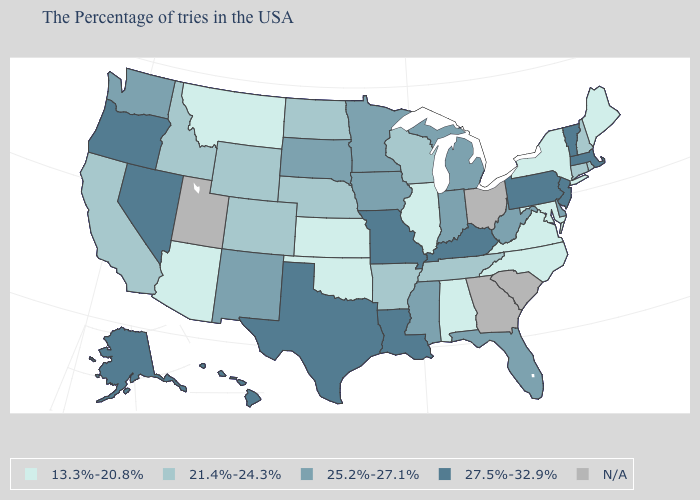Does Louisiana have the highest value in the South?
Write a very short answer. Yes. Name the states that have a value in the range 21.4%-24.3%?
Give a very brief answer. Rhode Island, New Hampshire, Connecticut, Tennessee, Wisconsin, Arkansas, Nebraska, North Dakota, Wyoming, Colorado, Idaho, California. What is the value of Nevada?
Answer briefly. 27.5%-32.9%. Which states have the lowest value in the South?
Concise answer only. Maryland, Virginia, North Carolina, Alabama, Oklahoma. What is the value of Connecticut?
Keep it brief. 21.4%-24.3%. What is the value of Arkansas?
Give a very brief answer. 21.4%-24.3%. What is the value of Washington?
Give a very brief answer. 25.2%-27.1%. What is the lowest value in the USA?
Answer briefly. 13.3%-20.8%. Name the states that have a value in the range 25.2%-27.1%?
Give a very brief answer. Delaware, West Virginia, Florida, Michigan, Indiana, Mississippi, Minnesota, Iowa, South Dakota, New Mexico, Washington. What is the value of Alaska?
Short answer required. 27.5%-32.9%. Does New York have the lowest value in the USA?
Concise answer only. Yes. What is the value of Louisiana?
Give a very brief answer. 27.5%-32.9%. Name the states that have a value in the range 27.5%-32.9%?
Be succinct. Massachusetts, Vermont, New Jersey, Pennsylvania, Kentucky, Louisiana, Missouri, Texas, Nevada, Oregon, Alaska, Hawaii. What is the lowest value in states that border Mississippi?
Short answer required. 13.3%-20.8%. Which states have the lowest value in the USA?
Short answer required. Maine, New York, Maryland, Virginia, North Carolina, Alabama, Illinois, Kansas, Oklahoma, Montana, Arizona. 